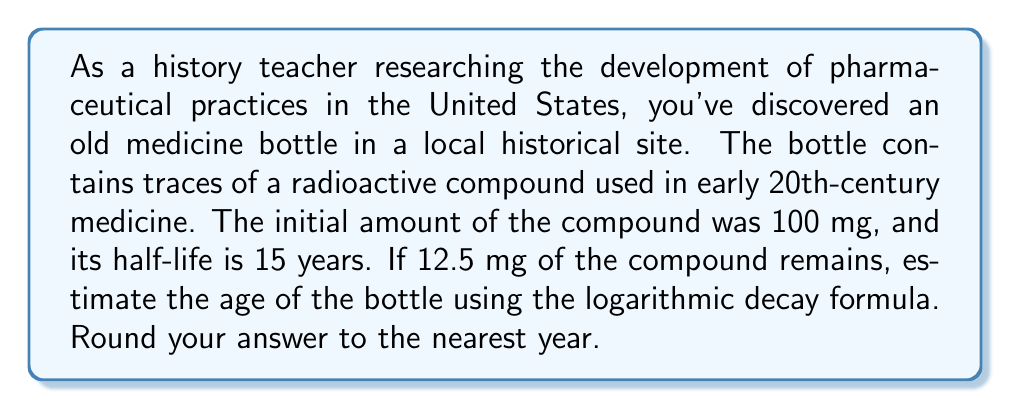Show me your answer to this math problem. Let's approach this step-by-step using the logarithmic decay formula:

1) The general form of the logarithmic decay formula is:
   $$t = \frac{\ln(\frac{A}{A_0})}{-\lambda}$$
   Where:
   $t$ is the time elapsed
   $A$ is the amount remaining
   $A_0$ is the initial amount
   $\lambda$ is the decay constant

2) We know:
   $A_0 = 100$ mg
   $A = 12.5$ mg
   Half-life = 15 years

3) We need to find $\lambda$ using the half-life:
   $$\lambda = \frac{\ln(2)}{\text{half-life}} = \frac{\ln(2)}{15} \approx 0.0462$$

4) Now we can plug these values into our formula:
   $$t = \frac{\ln(\frac{12.5}{100})}{-0.0462}$$

5) Simplify inside the logarithm:
   $$t = \frac{\ln(0.125)}{-0.0462}$$

6) Calculate:
   $$t \approx 45.11 \text{ years}$$

7) Rounding to the nearest year:
   $$t \approx 45 \text{ years}$$

Therefore, the estimated age of the bottle is approximately 45 years.
Answer: 45 years 